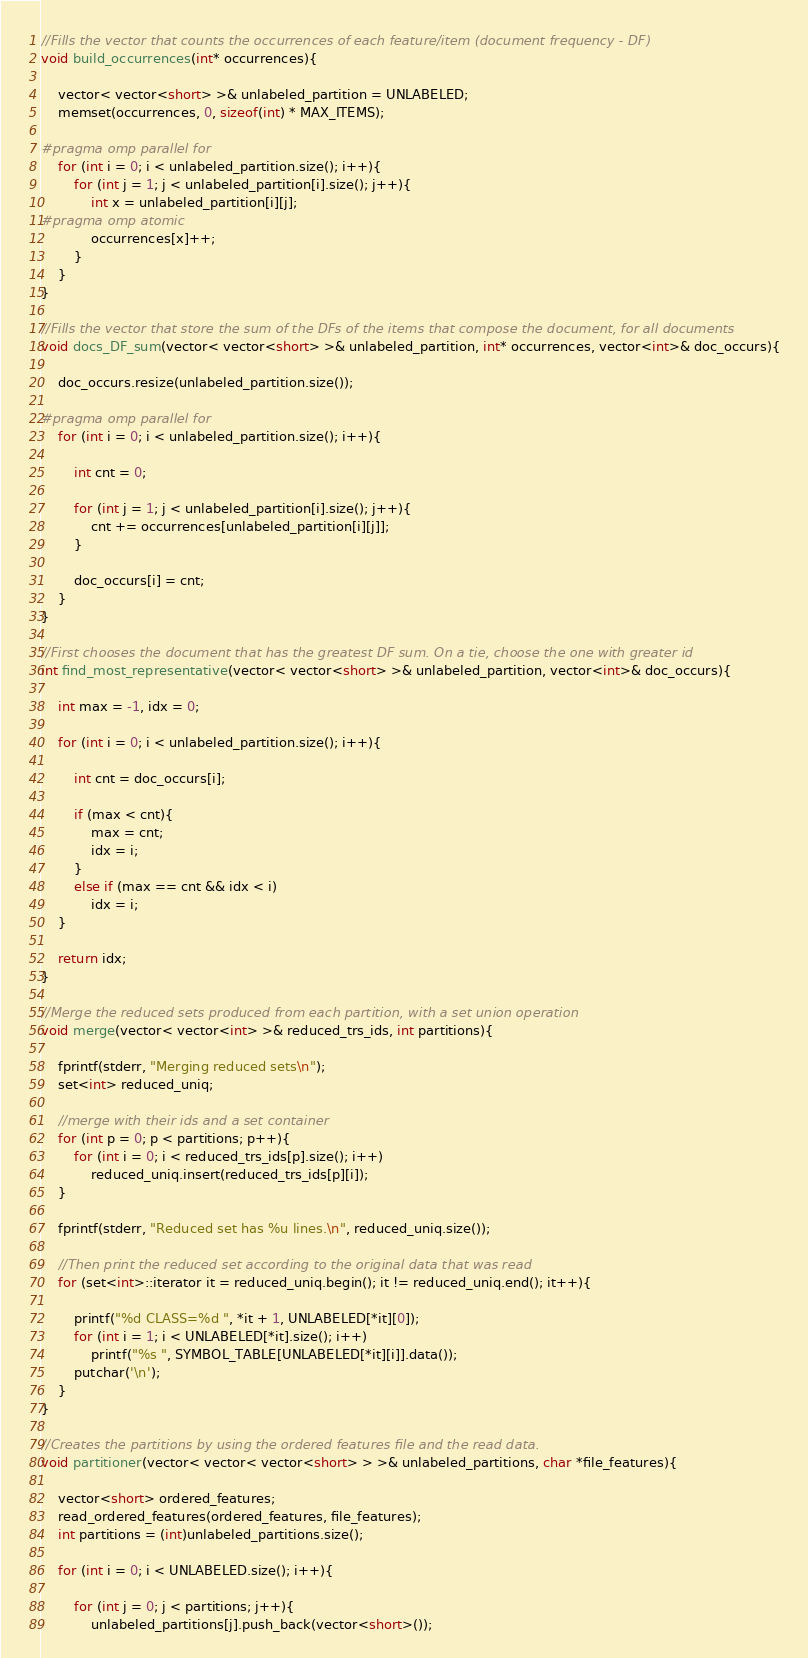Convert code to text. <code><loc_0><loc_0><loc_500><loc_500><_Cuda_>
//Fills the vector that counts the occurrences of each feature/item (document frequency - DF) 
void build_occurrences(int* occurrences){

	vector< vector<short> >& unlabeled_partition = UNLABELED;
	memset(occurrences, 0, sizeof(int) * MAX_ITEMS);

#pragma omp parallel for	
	for (int i = 0; i < unlabeled_partition.size(); i++){
		for (int j = 1; j < unlabeled_partition[i].size(); j++){
			int x = unlabeled_partition[i][j];
#pragma omp atomic
			occurrences[x]++;
		}
	}
}

//Fills the vector that store the sum of the DFs of the items that compose the document, for all documents
void docs_DF_sum(vector< vector<short> >& unlabeled_partition, int* occurrences, vector<int>& doc_occurs){

	doc_occurs.resize(unlabeled_partition.size());

#pragma omp parallel for
	for (int i = 0; i < unlabeled_partition.size(); i++){

		int cnt = 0;

		for (int j = 1; j < unlabeled_partition[i].size(); j++){
			cnt += occurrences[unlabeled_partition[i][j]];
		}

		doc_occurs[i] = cnt;
	}
}

//First chooses the document that has the greatest DF sum. On a tie, choose the one with greater id
int find_most_representative(vector< vector<short> >& unlabeled_partition, vector<int>& doc_occurs){

	int max = -1, idx = 0;

	for (int i = 0; i < unlabeled_partition.size(); i++){

		int cnt = doc_occurs[i];

		if (max < cnt){
			max = cnt;
			idx = i;
		}
		else if (max == cnt && idx < i)
			idx = i;
	}

	return idx;
}

//Merge the reduced sets produced from each partition, with a set union operation
void merge(vector< vector<int> >& reduced_trs_ids, int partitions){

	fprintf(stderr, "Merging reduced sets\n");
	set<int> reduced_uniq;

	//merge with their ids and a set container
	for (int p = 0; p < partitions; p++){
		for (int i = 0; i < reduced_trs_ids[p].size(); i++)
			reduced_uniq.insert(reduced_trs_ids[p][i]);
	}

	fprintf(stderr, "Reduced set has %u lines.\n", reduced_uniq.size());

	//Then print the reduced set according to the original data that was read
	for (set<int>::iterator it = reduced_uniq.begin(); it != reduced_uniq.end(); it++){

		printf("%d CLASS=%d ", *it + 1, UNLABELED[*it][0]);
		for (int i = 1; i < UNLABELED[*it].size(); i++)
			printf("%s ", SYMBOL_TABLE[UNLABELED[*it][i]].data());
		putchar('\n');
	}
}

//Creates the partitions by using the ordered features file and the read data.
void partitioner(vector< vector< vector<short> > >& unlabeled_partitions, char *file_features){

	vector<short> ordered_features;
	read_ordered_features(ordered_features, file_features);
	int partitions = (int)unlabeled_partitions.size();

	for (int i = 0; i < UNLABELED.size(); i++){

		for (int j = 0; j < partitions; j++){
			unlabeled_partitions[j].push_back(vector<short>());</code> 